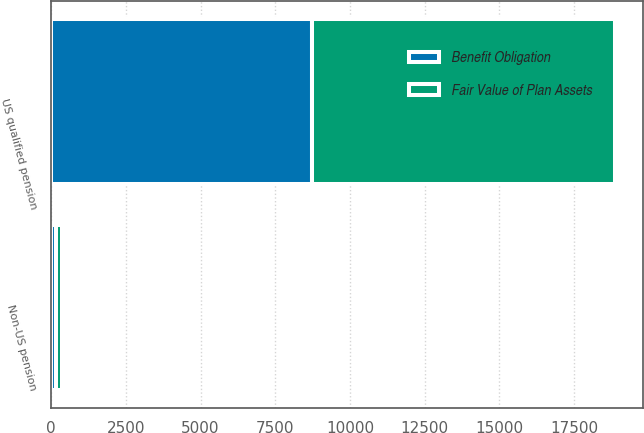Convert chart. <chart><loc_0><loc_0><loc_500><loc_500><stacked_bar_chart><ecel><fcel>US qualified pension<fcel>Non-US pension<nl><fcel>Fair Value of Plan Assets<fcel>10124<fcel>215<nl><fcel>Benefit Obligation<fcel>8735<fcel>161<nl></chart> 